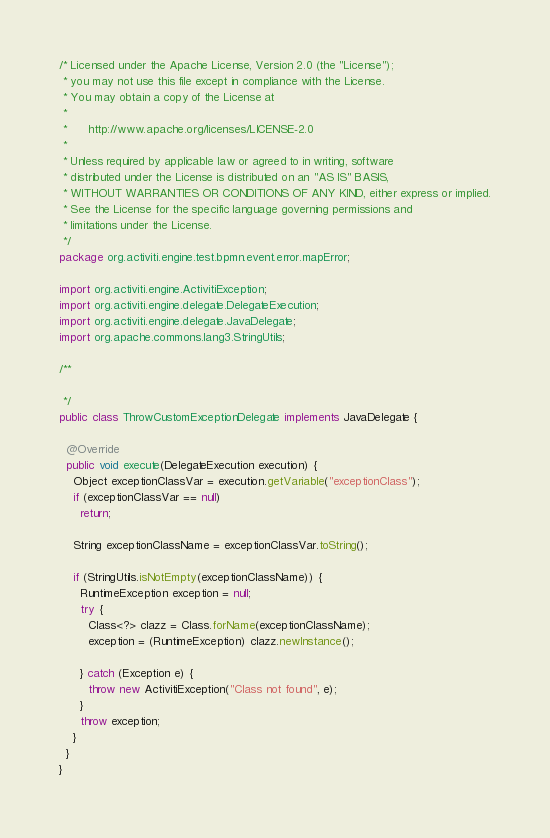<code> <loc_0><loc_0><loc_500><loc_500><_Java_>/* Licensed under the Apache License, Version 2.0 (the "License");
 * you may not use this file except in compliance with the License.
 * You may obtain a copy of the License at
 * 
 *      http://www.apache.org/licenses/LICENSE-2.0
 * 
 * Unless required by applicable law or agreed to in writing, software
 * distributed under the License is distributed on an "AS IS" BASIS,
 * WITHOUT WARRANTIES OR CONDITIONS OF ANY KIND, either express or implied.
 * See the License for the specific language governing permissions and
 * limitations under the License.
 */
package org.activiti.engine.test.bpmn.event.error.mapError;

import org.activiti.engine.ActivitiException;
import org.activiti.engine.delegate.DelegateExecution;
import org.activiti.engine.delegate.JavaDelegate;
import org.apache.commons.lang3.StringUtils;

/**

 */
public class ThrowCustomExceptionDelegate implements JavaDelegate {

  @Override
  public void execute(DelegateExecution execution) {
    Object exceptionClassVar = execution.getVariable("exceptionClass");
    if (exceptionClassVar == null)
      return;

    String exceptionClassName = exceptionClassVar.toString();

    if (StringUtils.isNotEmpty(exceptionClassName)) {
      RuntimeException exception = null;
      try {
        Class<?> clazz = Class.forName(exceptionClassName);
        exception = (RuntimeException) clazz.newInstance();

      } catch (Exception e) {
        throw new ActivitiException("Class not found", e);
      }
      throw exception;
    }
  }
}
</code> 